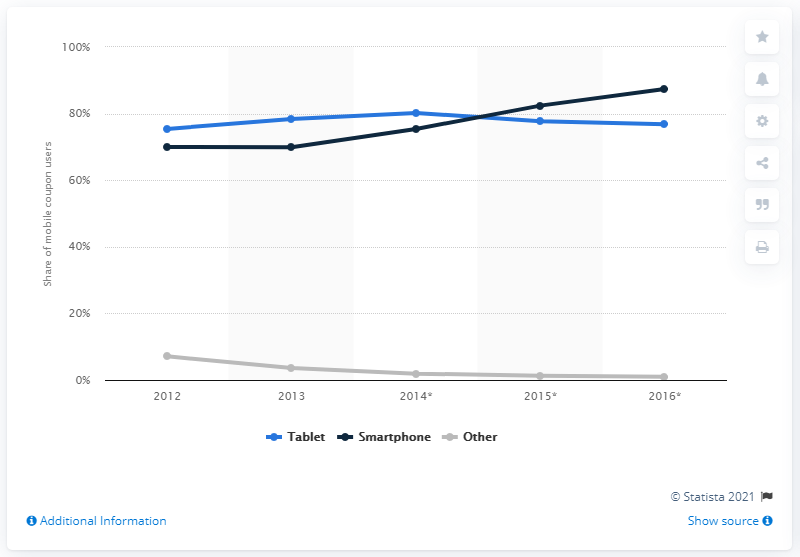Highlight a few significant elements in this photo. In 2013, 77.7% of mobile coupon users accessed coupons via tablet devices. 